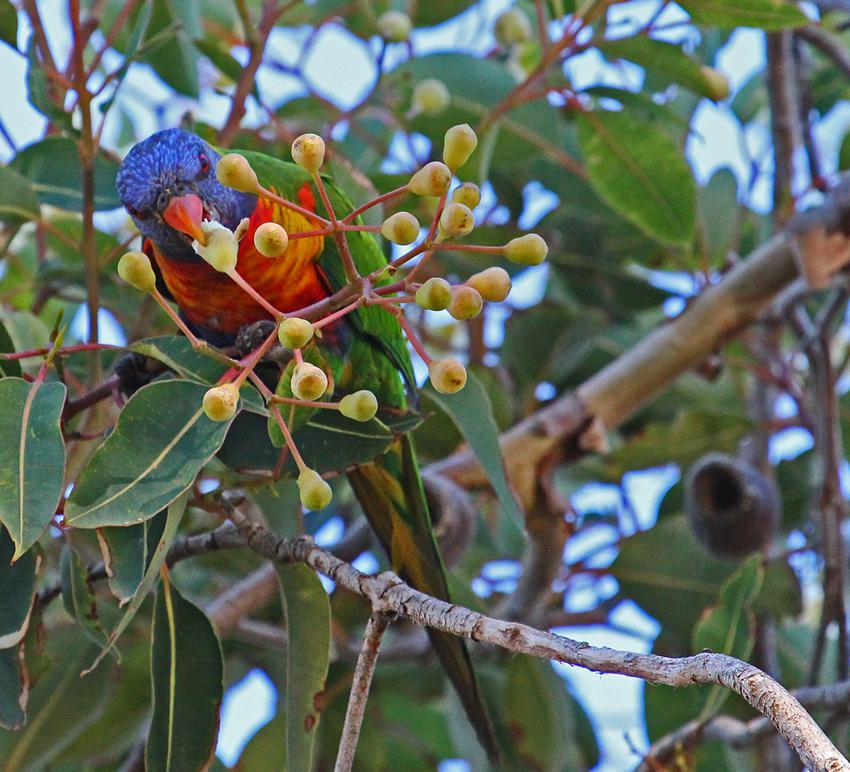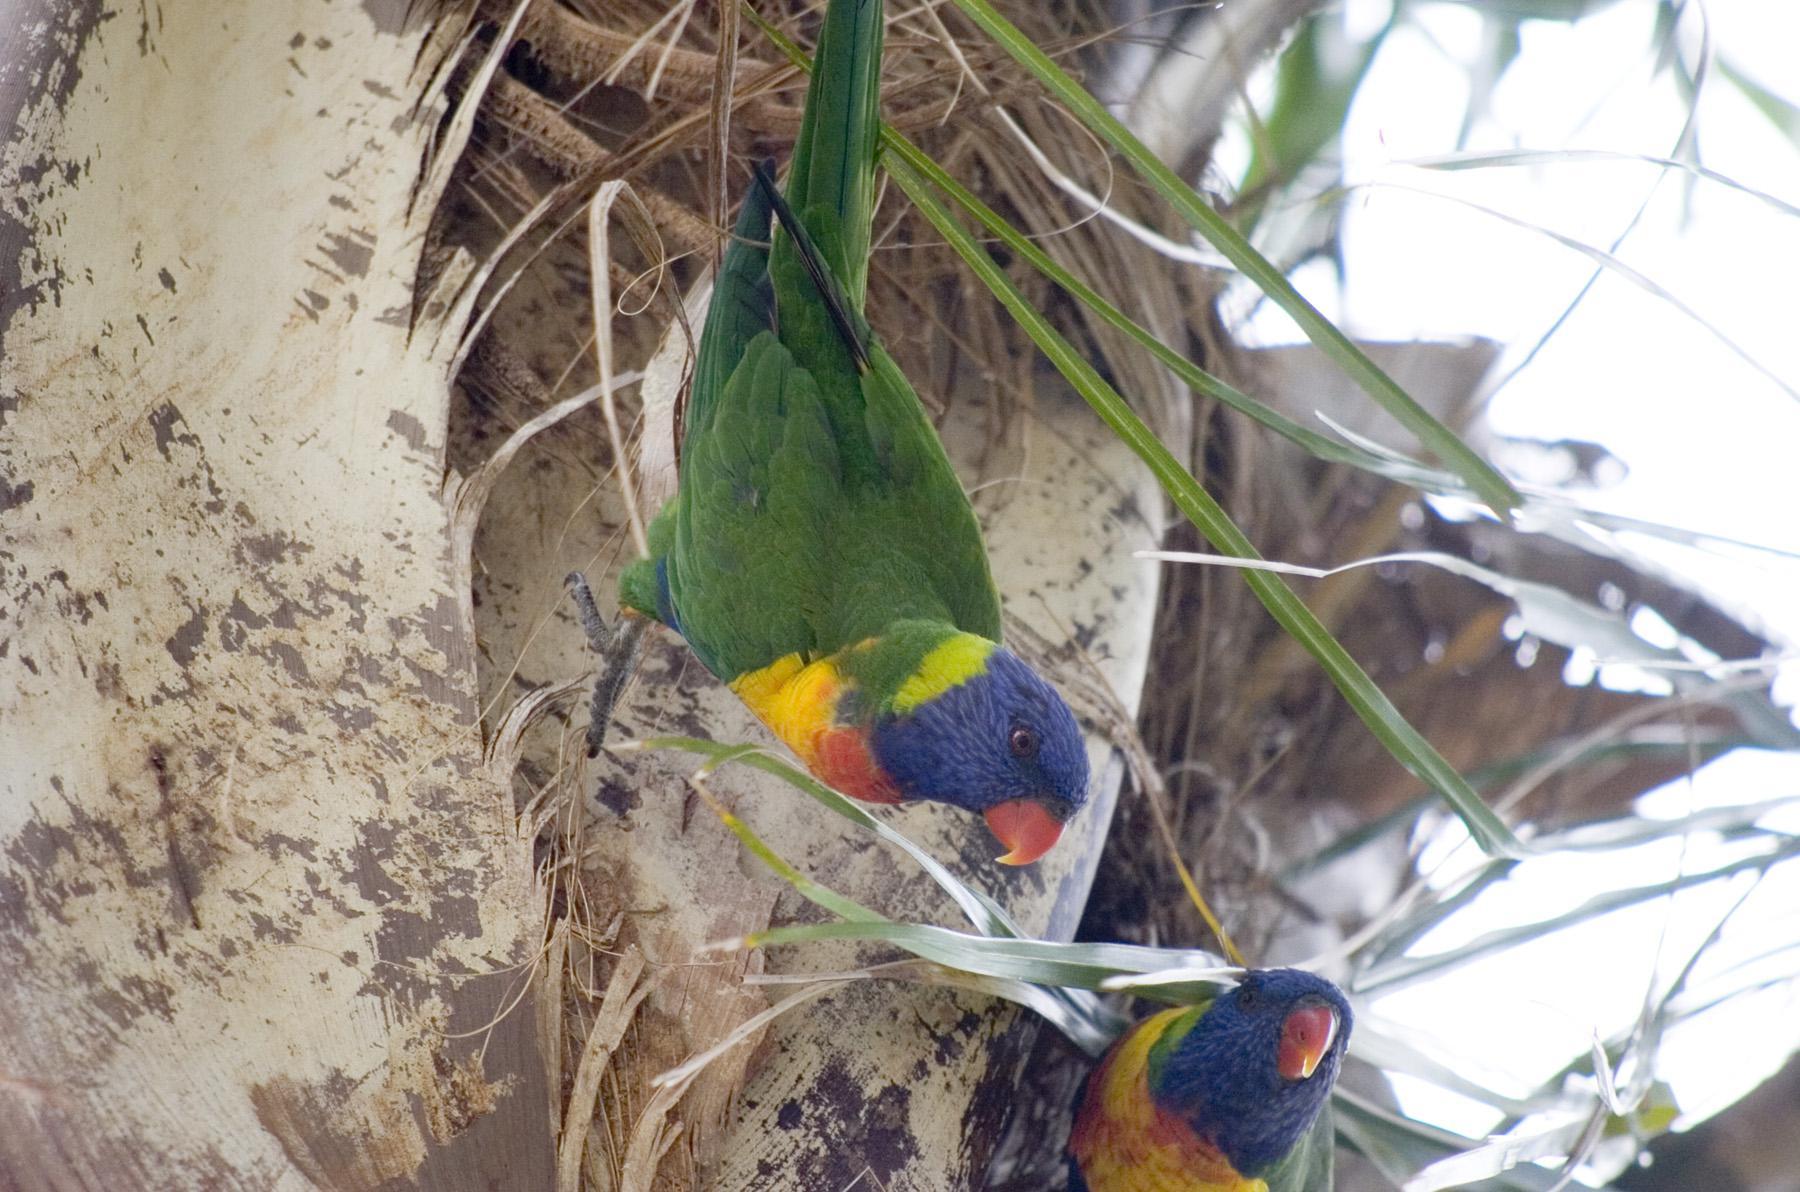The first image is the image on the left, the second image is the image on the right. For the images shown, is this caption "Both pictures have an identical number of parrots perched on branches in the foreground." true? Answer yes or no. No. The first image is the image on the left, the second image is the image on the right. Analyze the images presented: Is the assertion "The image on the right contains two parrots." valid? Answer yes or no. Yes. 